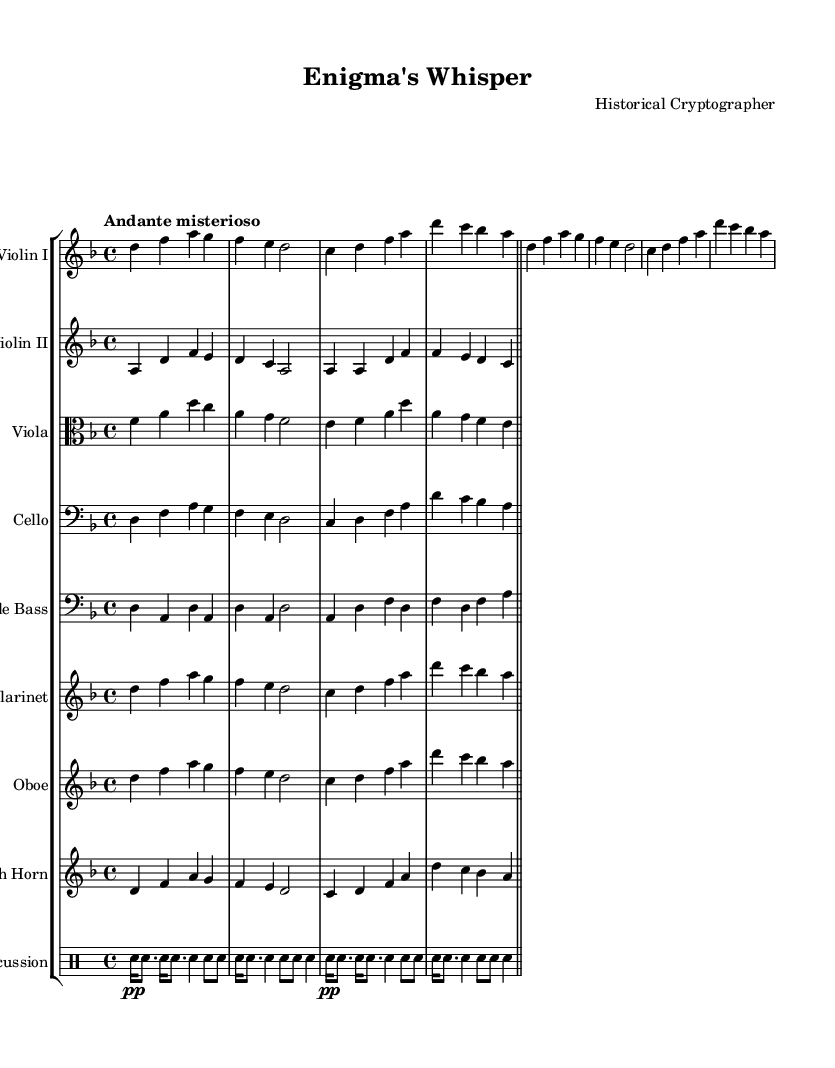What is the key signature of this music? The key signature is indicated at the beginning of the score, showing that it is in D minor, which features one flat.
Answer: D minor What is the time signature of this piece? The time signature is found at the beginning of the score, indicating that the piece is in four beats per measure with a quarter note getting one beat.
Answer: 4/4 What is the tempo of this composition? The tempo marking is stated at the beginning of the score, which describes a slow, mysterious pace for the piece.
Answer: Andante misterioso How many staves are in the score? Counting the number of separate lines that represent different instruments in the score reveals that there are a total of nine staves represented.
Answer: 9 Which instrument has a transposition indicated, and what is the transposition for it? The clarinet and French horn are noted as transposed instruments in the score; the clarinet transposes down a major second (B flat) and the French horn transposes up a perfect fifth (F).
Answer: B flat Which instrument plays the percussion part? The score includes a specific staff for the percussion, indicating which sections are designated for percussion instruments within the composition.
Answer: Percussion What is the rhythmic pattern used in the percussion section? Analyzing the rhythmic notation in the percussion staff shows a sequence of snare drum notes in various rhythmic values, creating a flowing, dynamic pattern throughout the piece.
Answer: Snare drum 